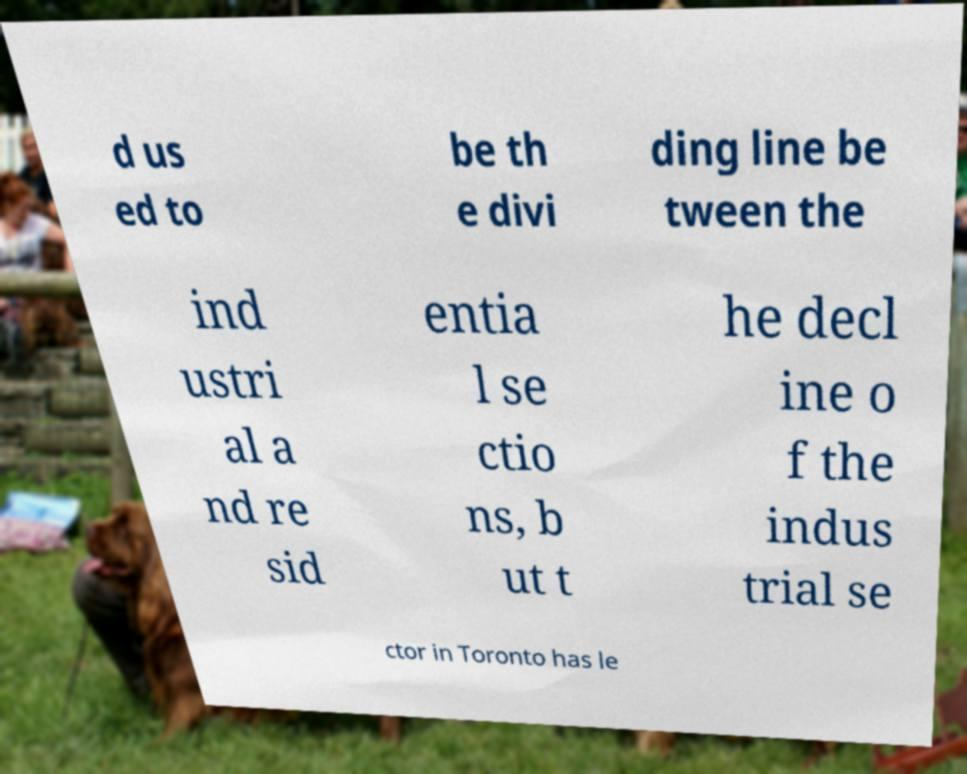What messages or text are displayed in this image? I need them in a readable, typed format. d us ed to be th e divi ding line be tween the ind ustri al a nd re sid entia l se ctio ns, b ut t he decl ine o f the indus trial se ctor in Toronto has le 